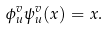<formula> <loc_0><loc_0><loc_500><loc_500>\phi _ { u } ^ { v } \psi _ { u } ^ { v } ( x ) = x .</formula> 